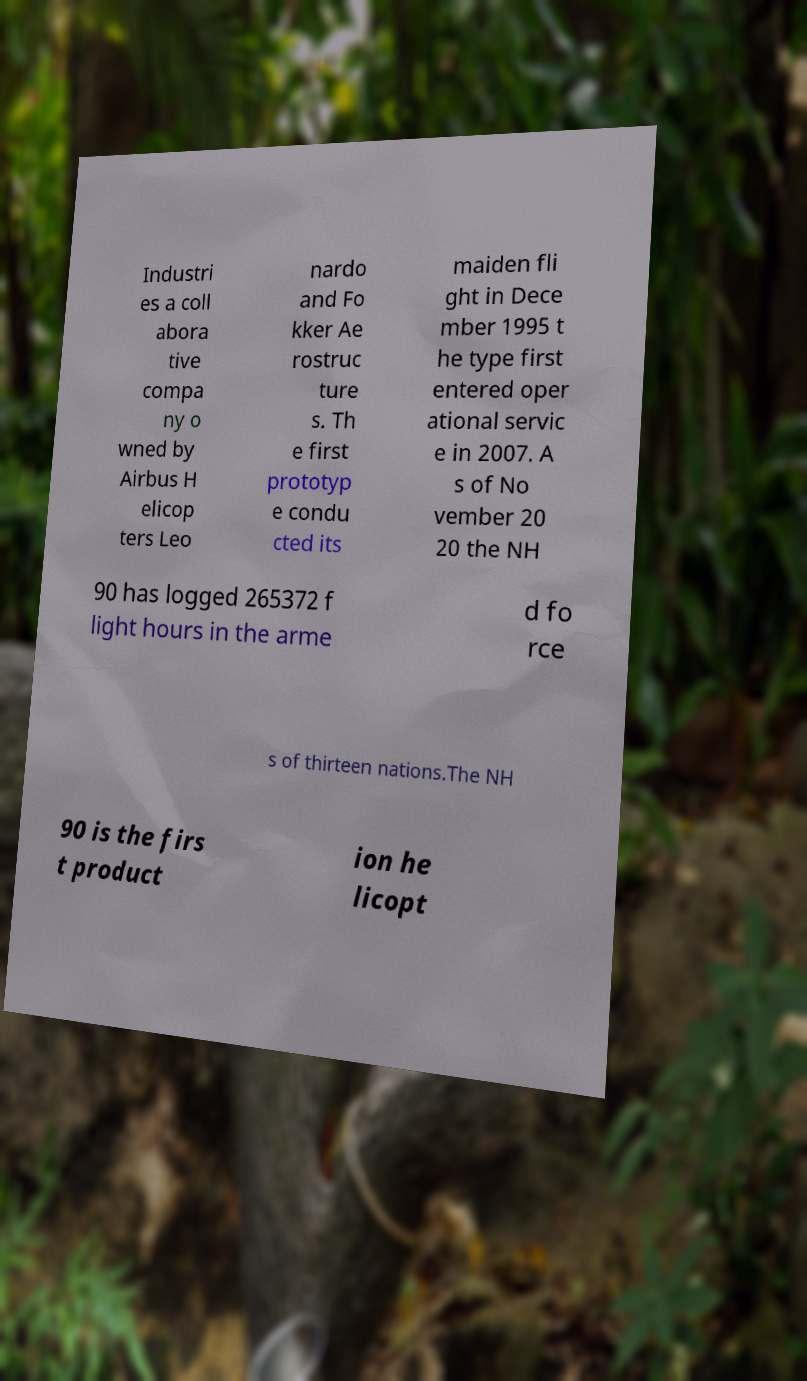Could you extract and type out the text from this image? Industri es a coll abora tive compa ny o wned by Airbus H elicop ters Leo nardo and Fo kker Ae rostruc ture s. Th e first prototyp e condu cted its maiden fli ght in Dece mber 1995 t he type first entered oper ational servic e in 2007. A s of No vember 20 20 the NH 90 has logged 265372 f light hours in the arme d fo rce s of thirteen nations.The NH 90 is the firs t product ion he licopt 